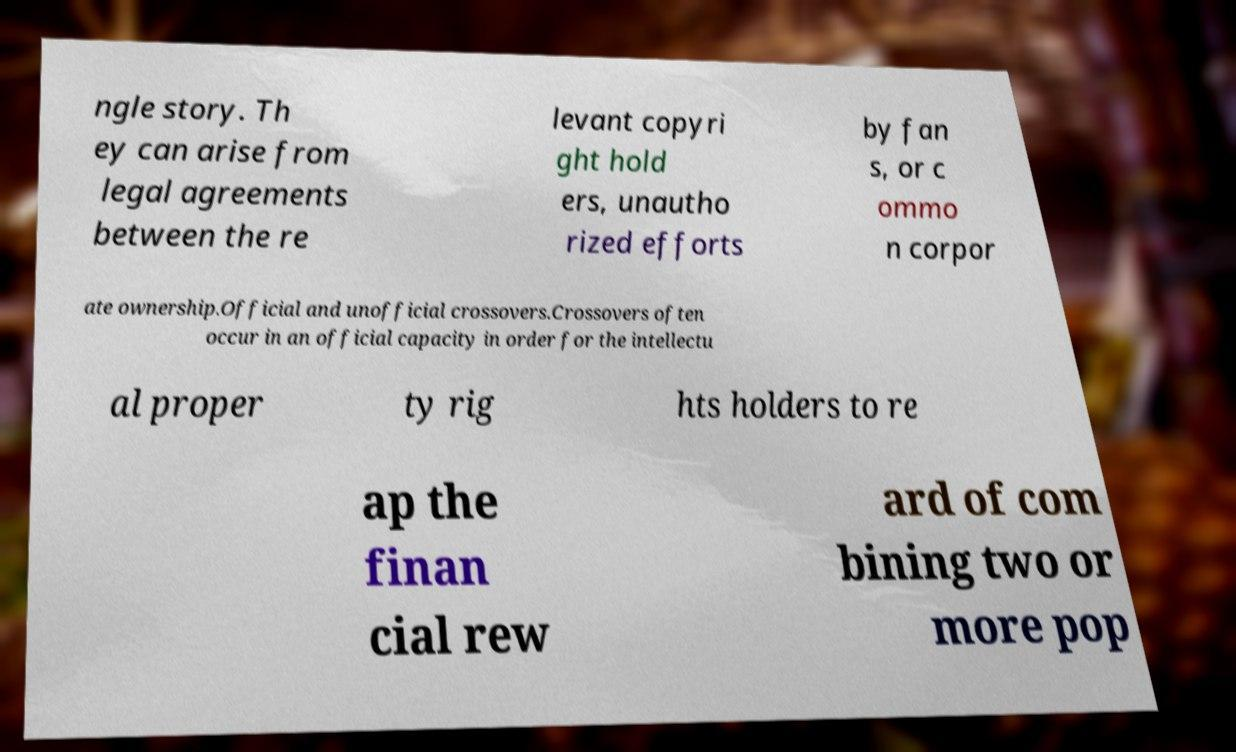I need the written content from this picture converted into text. Can you do that? ngle story. Th ey can arise from legal agreements between the re levant copyri ght hold ers, unautho rized efforts by fan s, or c ommo n corpor ate ownership.Official and unofficial crossovers.Crossovers often occur in an official capacity in order for the intellectu al proper ty rig hts holders to re ap the finan cial rew ard of com bining two or more pop 